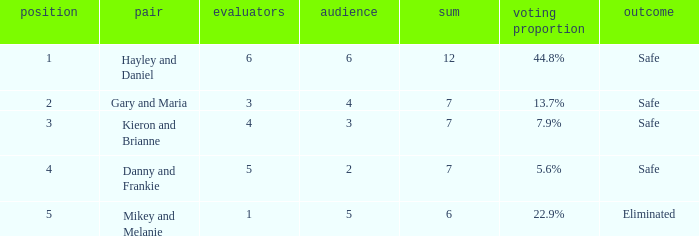How many judges were there for the eliminated couple?  1.0. 